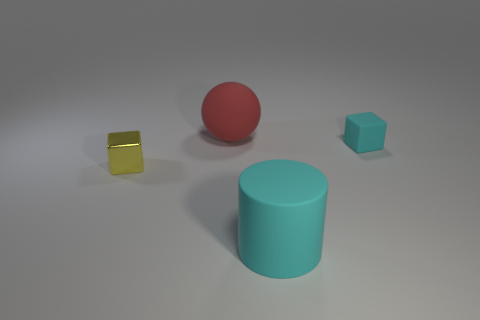What is the shape of the object that is the same color as the big rubber cylinder?
Give a very brief answer. Cube. How many large cylinders are the same material as the big sphere?
Your answer should be compact. 1. There is a small block that is the same material as the big cyan object; what color is it?
Your response must be concise. Cyan. Is the number of rubber blocks less than the number of small red shiny balls?
Ensure brevity in your answer.  No. There is a big object that is left of the large matte thing that is on the right side of the matte sphere behind the yellow shiny block; what is it made of?
Provide a succinct answer. Rubber. What material is the ball?
Provide a succinct answer. Rubber. Does the object in front of the yellow cube have the same color as the tiny block on the left side of the large ball?
Make the answer very short. No. Is the number of tiny matte cubes greater than the number of brown rubber balls?
Give a very brief answer. Yes. How many other spheres are the same color as the big sphere?
Provide a short and direct response. 0. What is the color of the other rubber thing that is the same shape as the yellow thing?
Ensure brevity in your answer.  Cyan. 